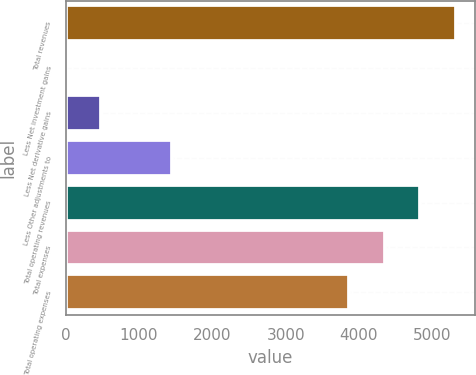Convert chart to OTSL. <chart><loc_0><loc_0><loc_500><loc_500><bar_chart><fcel>Total revenues<fcel>Less Net investment gains<fcel>Less Net derivative gains<fcel>Less Other adjustments to<fcel>Total operating revenues<fcel>Total expenses<fcel>Total operating expenses<nl><fcel>5316.9<fcel>2<fcel>486.3<fcel>1454.9<fcel>4832.6<fcel>4348.3<fcel>3864<nl></chart> 